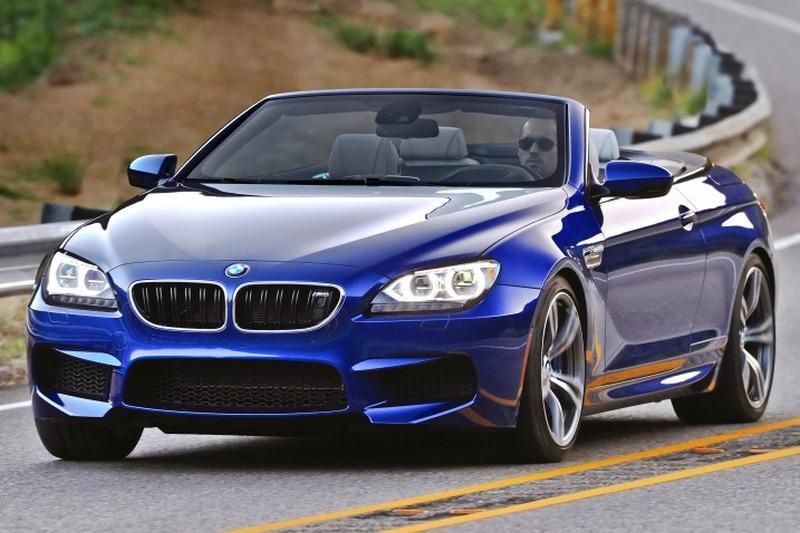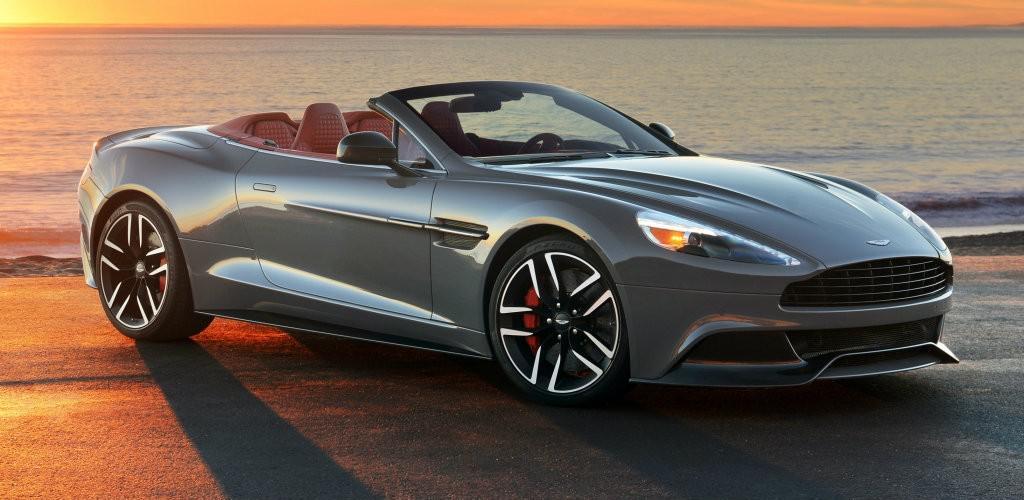The first image is the image on the left, the second image is the image on the right. Analyze the images presented: Is the assertion "An image shows a bright blue convertible with its top down." valid? Answer yes or no. Yes. The first image is the image on the left, the second image is the image on the right. Assess this claim about the two images: "There is a blue car in the left image.". Correct or not? Answer yes or no. Yes. 